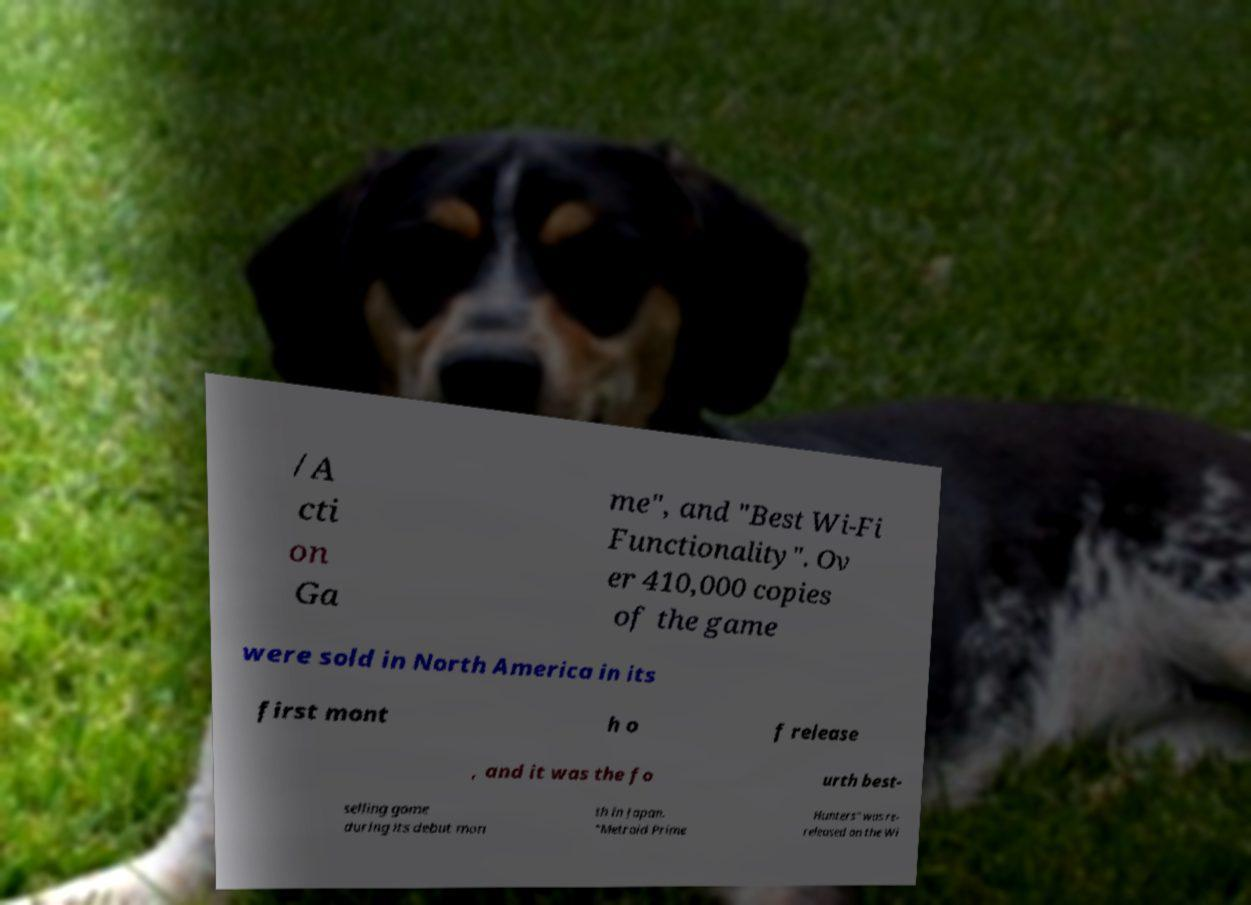Can you read and provide the text displayed in the image?This photo seems to have some interesting text. Can you extract and type it out for me? /A cti on Ga me", and "Best Wi-Fi Functionality". Ov er 410,000 copies of the game were sold in North America in its first mont h o f release , and it was the fo urth best- selling game during its debut mon th in Japan. "Metroid Prime Hunters" was re- released on the Wi 